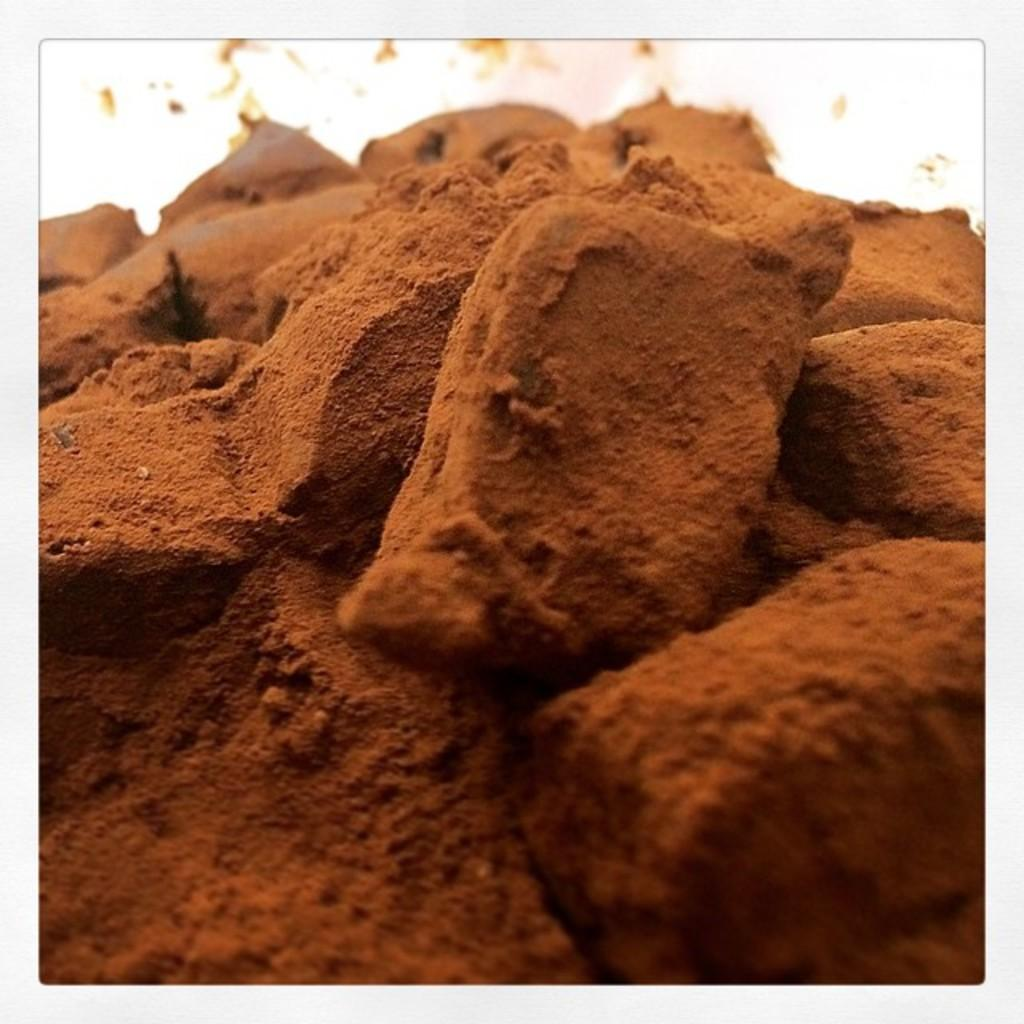What type of material is featured in the image? There are mud bricks in the image. Can you describe the background of the image? The background of the image is blurred. What type of jelly can be seen in the image? There is no jelly present in the image; it features mud bricks. What architectural feature is visible in the image? The image does not show any specific architectural features, only mud bricks. 